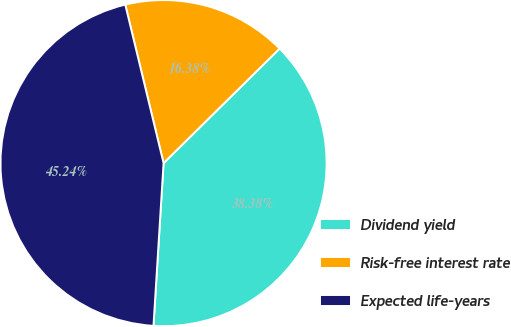<chart> <loc_0><loc_0><loc_500><loc_500><pie_chart><fcel>Dividend yield<fcel>Risk-free interest rate<fcel>Expected life-years<nl><fcel>38.38%<fcel>16.38%<fcel>45.24%<nl></chart> 